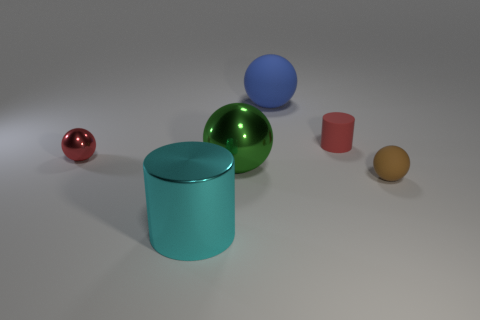Add 2 blue rubber spheres. How many objects exist? 8 Subtract all blue balls. How many balls are left? 3 Subtract all cylinders. How many objects are left? 4 Subtract all gray balls. Subtract all brown blocks. How many balls are left? 4 Subtract all tiny brown things. Subtract all balls. How many objects are left? 1 Add 5 green metal balls. How many green metal balls are left? 6 Add 5 green balls. How many green balls exist? 6 Subtract 0 purple cylinders. How many objects are left? 6 